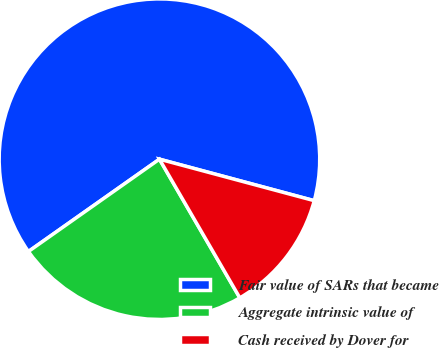Convert chart to OTSL. <chart><loc_0><loc_0><loc_500><loc_500><pie_chart><fcel>Fair value of SARs that became<fcel>Aggregate intrinsic value of<fcel>Cash received by Dover for<nl><fcel>63.94%<fcel>23.59%<fcel>12.47%<nl></chart> 